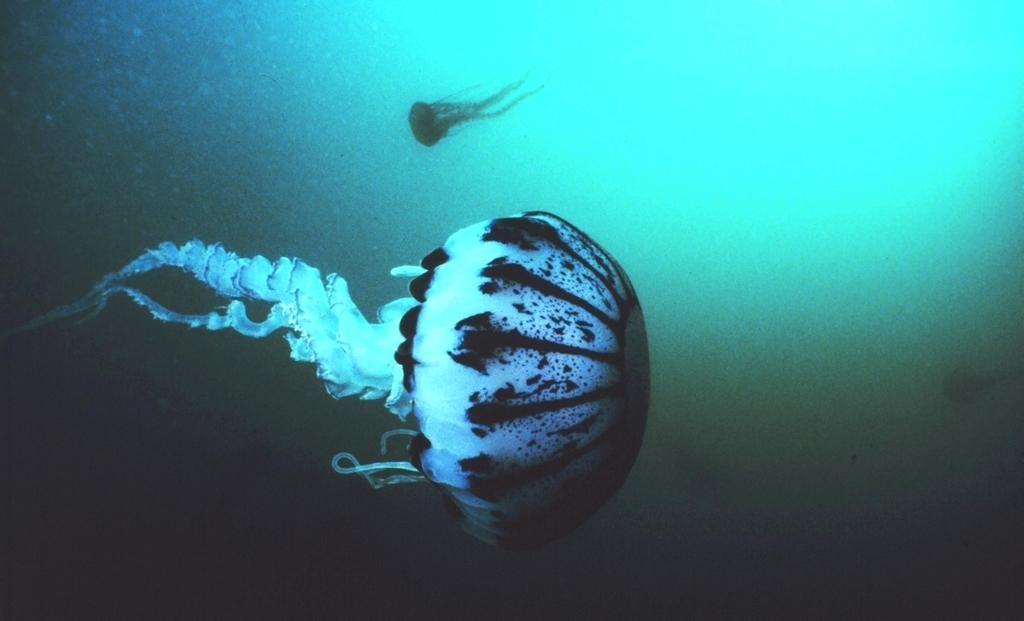Please provide a concise description of this image. In this image there are two ocean biomes present in the water. 